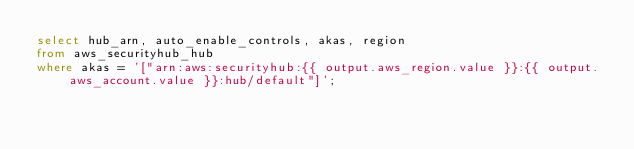Convert code to text. <code><loc_0><loc_0><loc_500><loc_500><_SQL_>select hub_arn, auto_enable_controls, akas, region
from aws_securityhub_hub
where akas = '["arn:aws:securityhub:{{ output.aws_region.value }}:{{ output.aws_account.value }}:hub/default"]';
</code> 